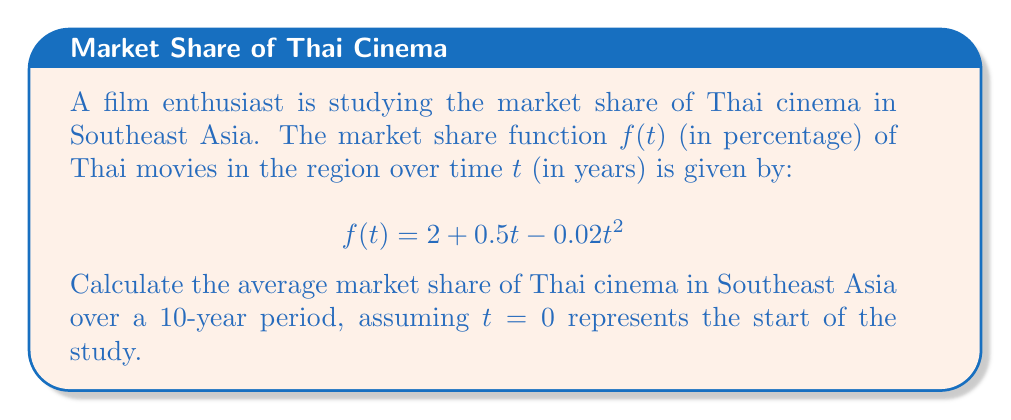Can you solve this math problem? To solve this problem, we need to use the concept of definite integrals to find the average value of a function over an interval. The steps are as follows:

1) The formula for the average value of a function $f(t)$ over an interval $[a,b]$ is:

   $$\text{Average} = \frac{1}{b-a} \int_{a}^{b} f(t) dt$$

2) In our case, $a=0$, $b=10$, and $f(t) = 2 + 0.5t - 0.02t^2$

3) Let's set up the integral:

   $$\text{Average} = \frac{1}{10-0} \int_{0}^{10} (2 + 0.5t - 0.02t^2) dt$$

4) Simplify:

   $$\text{Average} = \frac{1}{10} \int_{0}^{10} (2 + 0.5t - 0.02t^2) dt$$

5) Integrate each term:

   $$\text{Average} = \frac{1}{10} \left[2t + 0.25t^2 - \frac{0.02}{3}t^3\right]_{0}^{10}$$

6) Evaluate the integral:

   $$\text{Average} = \frac{1}{10} \left[(20 + 25 - \frac{200}{3}) - (0 + 0 - 0)\right]$$

7) Simplify:

   $$\text{Average} = \frac{1}{10} \left[45 - \frac{200}{3}\right] = 4.5 - \frac{20}{3} = \frac{13.5}{3} = 4.5$$

Therefore, the average market share of Thai cinema in Southeast Asia over the 10-year period is 4.5%.
Answer: 4.5% 